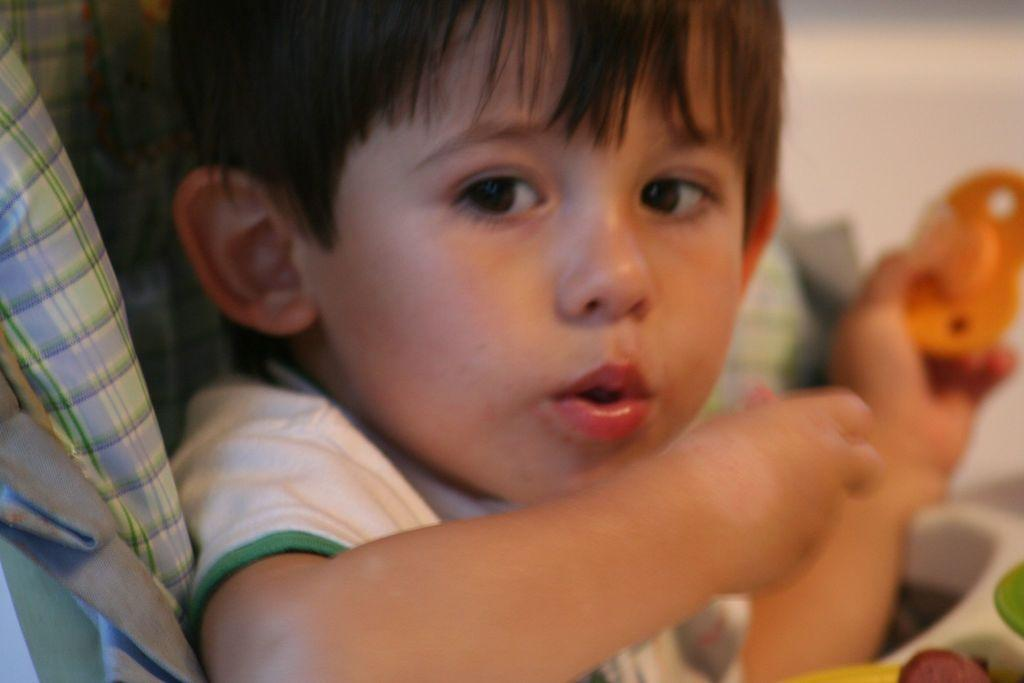Who is the main subject in the image? There is a boy in the image. What is the boy doing in the image? The boy is playing with toys. What is the boy wearing in the image? The boy is wearing a white t-shirt. Can you describe the background of the image? The background of the image is blurred. What can be seen to the left of the image? There is a cloth to the left of the image. How many feet are visible in the image? There is no information about feet in the image, as it focuses on the boy playing with toys. 